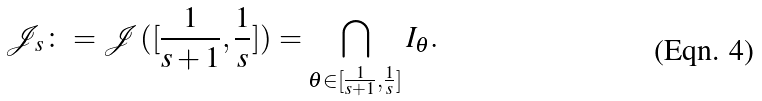<formula> <loc_0><loc_0><loc_500><loc_500>\mathcal { J } _ { s } \colon = \mathcal { J } ( [ \frac { 1 } { s + 1 } , \frac { 1 } { s } ] ) = \bigcap _ { \theta \in [ \frac { 1 } { s + 1 } , \frac { 1 } { s } ] } I _ { \theta } .</formula> 